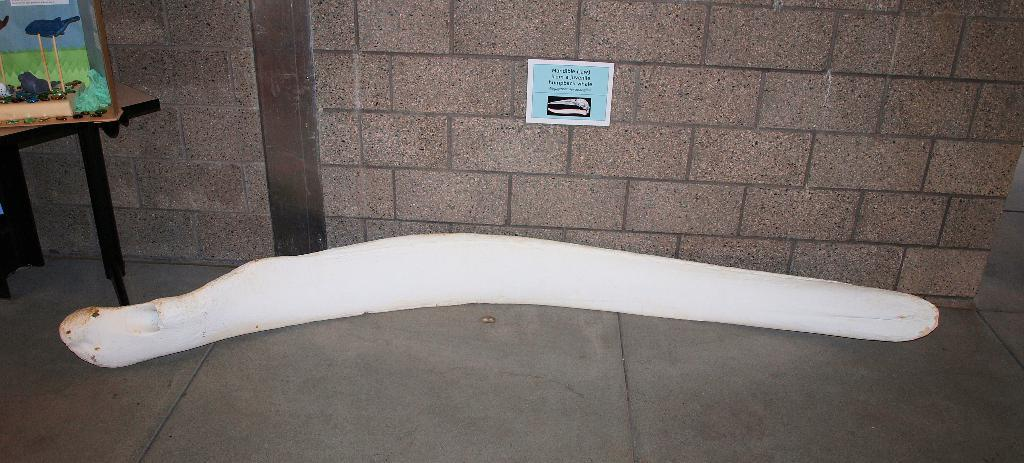What structure is located on the left side of the image? There is a table on the left side of the image. What type of object can be seen in the image that resembles a bone of an animal? There is an object that resembles a bone of an animal in the image. What is the color of the bone-like object? The bone-like object is white in color. Can you tell me how the loaf of bread is related to the fog in the image? There is no loaf of bread or fog present in the image. What type of roof is visible in the image? There is no roof visible in the image. 